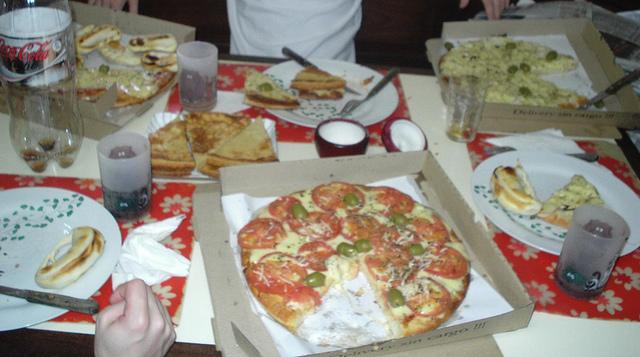What kind of pizza has the most eaten?
Concise answer only. Cheese. How many slices of pizza are missing?
Keep it brief. 1. Which pizza is pepperoni?
Quick response, please. None. Is this a good date dinner?
Concise answer only. Yes. What is on the napkins?
Give a very brief answer. Food. What type of dish is this?
Concise answer only. Pizza. How many plates are on the table?
Write a very short answer. 3. Is this a meal for one person?
Concise answer only. No. What meal is this?
Give a very brief answer. Dinner. What kind of party might be depicted here?
Short answer required. Pizza party. 